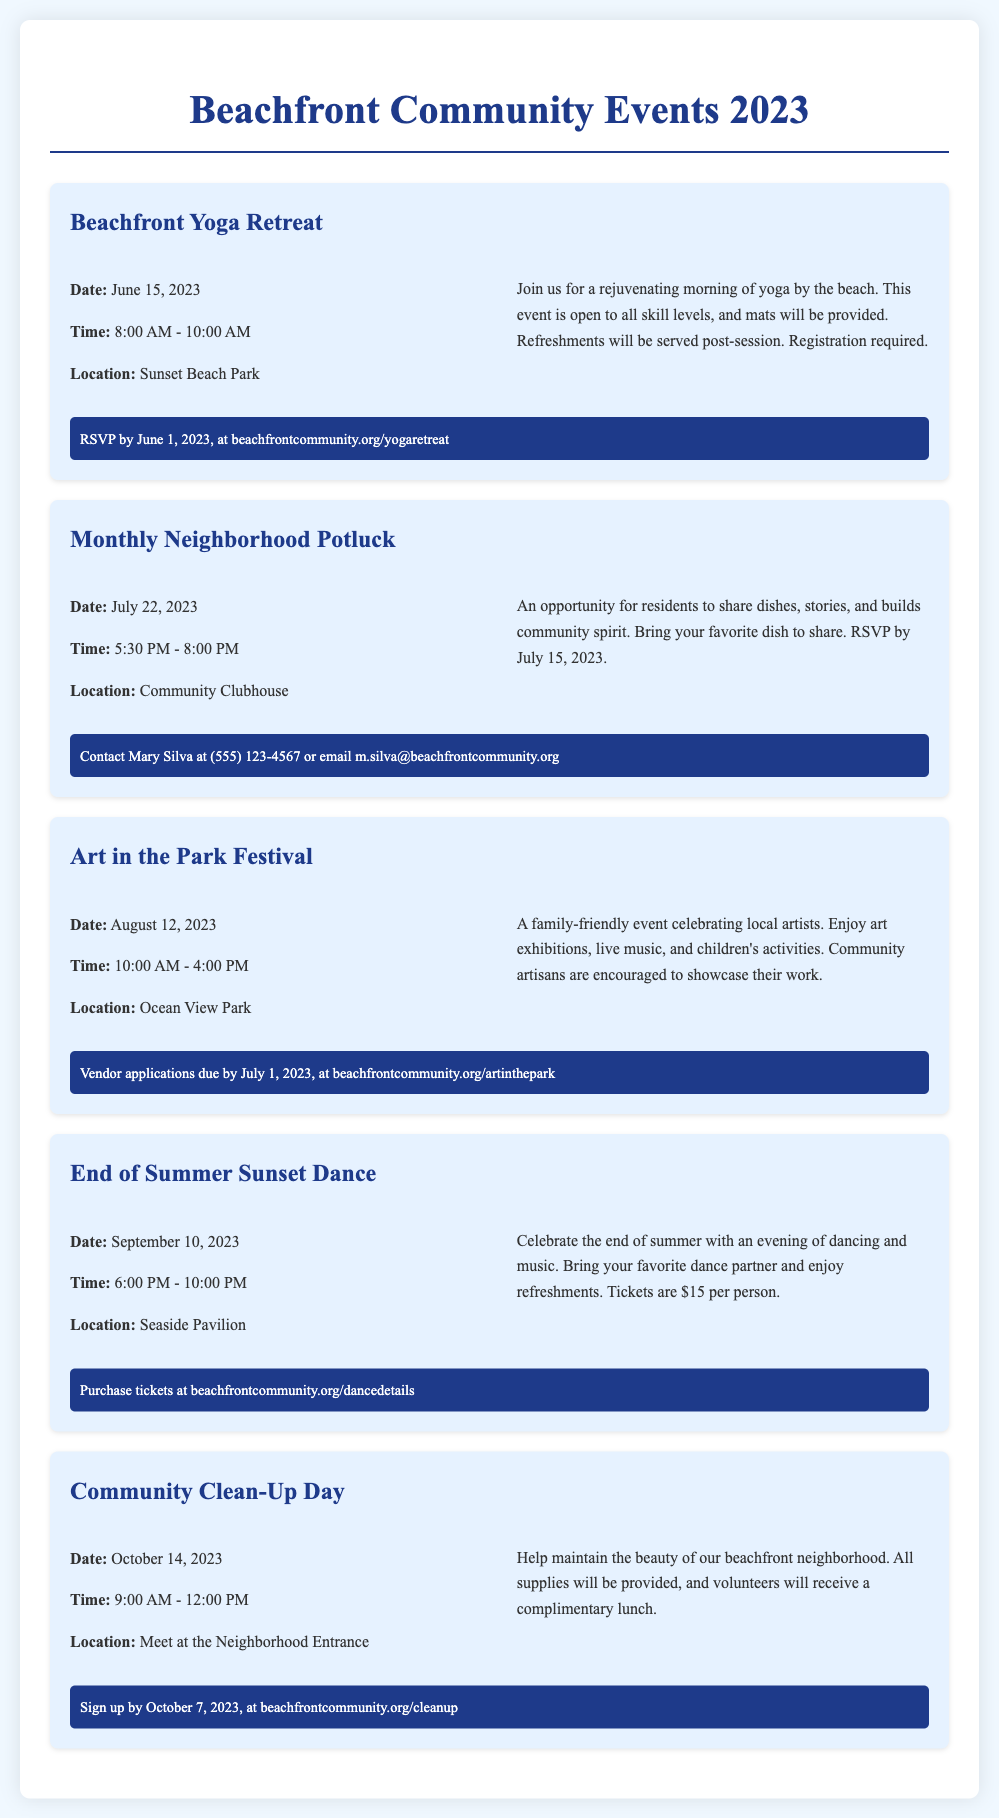What is the date of the Beachfront Yoga Retreat? The date is found in the event details section for the Beachfront Yoga Retreat.
Answer: June 15, 2023 What time does the Monthly Neighborhood Potluck start? The time is specified in the event details for the Monthly Neighborhood Potluck.
Answer: 5:30 PM Where is the Art in the Park Festival held? The location is mentioned in the event details for the Art in the Park Festival.
Answer: Ocean View Park How much are tickets for the End of Summer Sunset Dance? The ticket price is listed in the description of the End of Summer Sunset Dance.
Answer: $15 per person What is provided during the Community Clean-Up Day? The details mention what will be provided for volunteers during the Community Clean-Up Day.
Answer: Complimentary lunch When do vendor applications for Art in the Park Festival close? Vendor application deadlines are outlined in the registration section of the Art in the Park Festival event.
Answer: July 1, 2023 Which event requires an RSVP by June 1, 2023? The event requiring this RSVP date can be found in the Beachfront Yoga Retreat's registration details.
Answer: Beachfront Yoga Retreat What is the location for the Community Clean-Up Day? The location is specified in the Community Clean-Up Day event details.
Answer: Meet at the Neighborhood Entrance What type of activities can we expect at the Art in the Park Festival? The description section for the Art in the Park Festival outlines the activities included in this event.
Answer: Art exhibitions, live music, and children's activities 